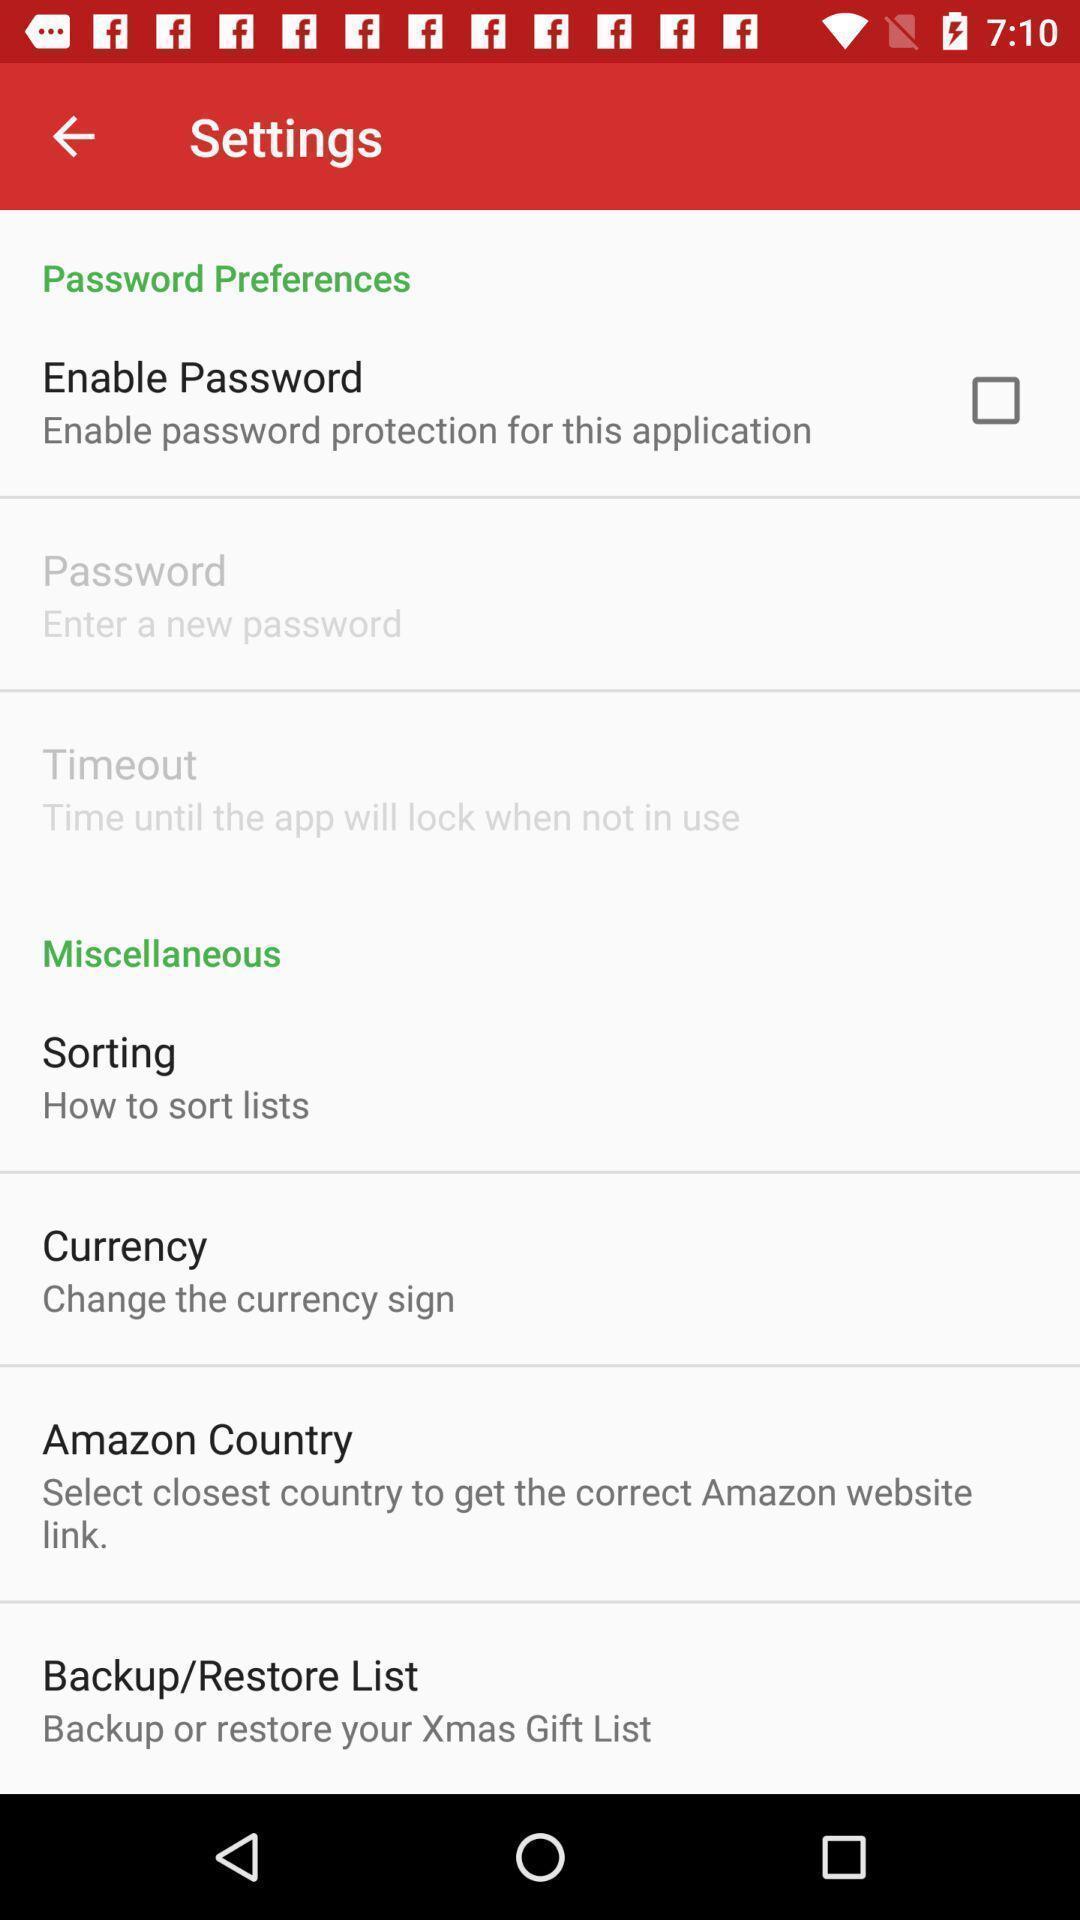Provide a textual representation of this image. Settings page. 